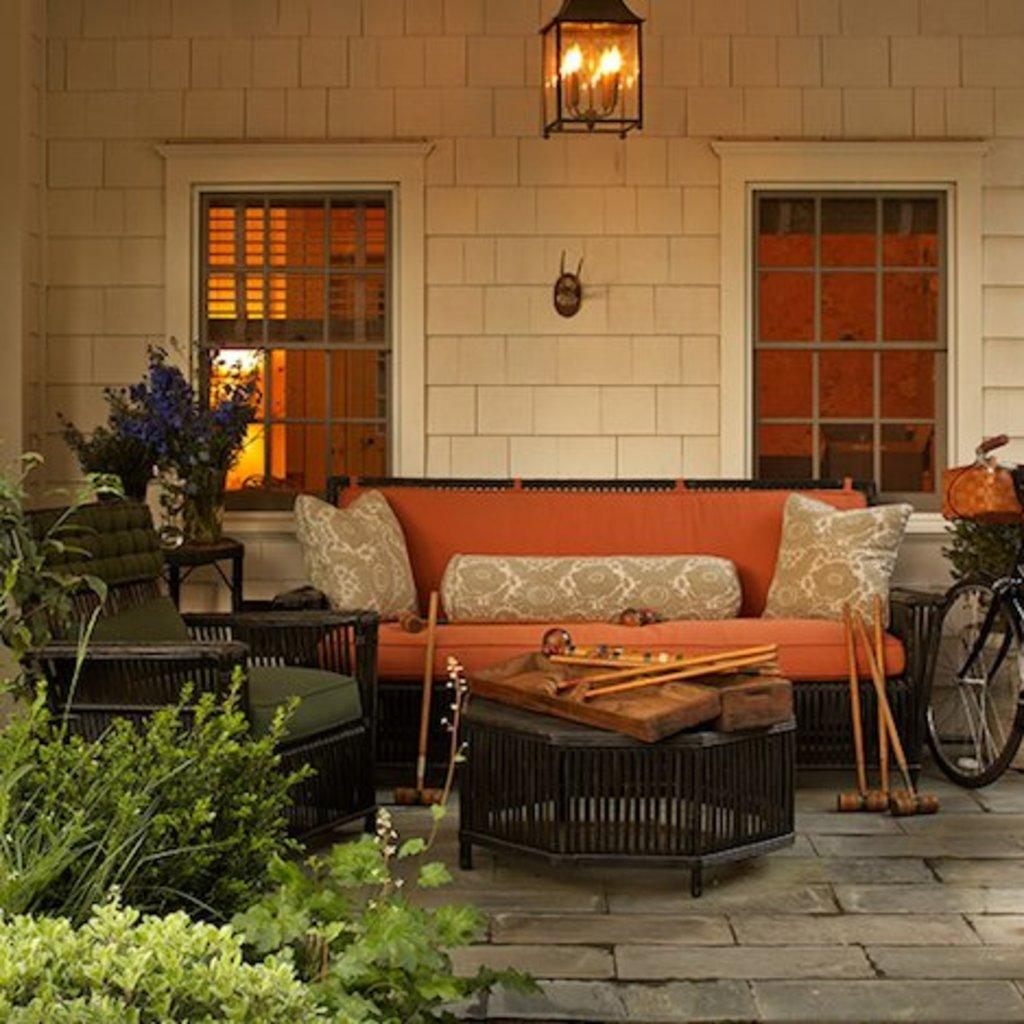What type of space is depicted in the image? There is a room in the image. What furniture is present in the room? There is a sofa and a chair in the room. What architectural features can be seen in the background of the image? There is a wall and a window visible in the background of the image. What object is on the right side of the image? There is a bicycle on the right side of the image. What type of vegetation is on the left side of the image? There are plants on the left side of the image. Where are the shoes placed in the image? There are no shoes present in the image. What type of notebook is visible on the chair in the image? There is no notebook present in the image. 